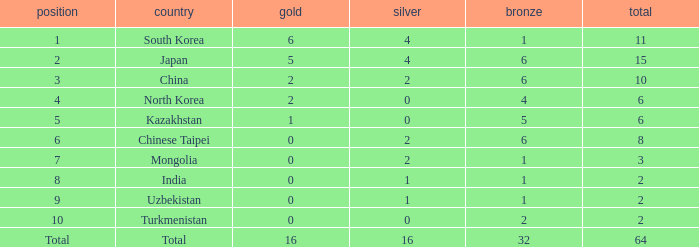What is the total Gold's less than 0? 0.0. 